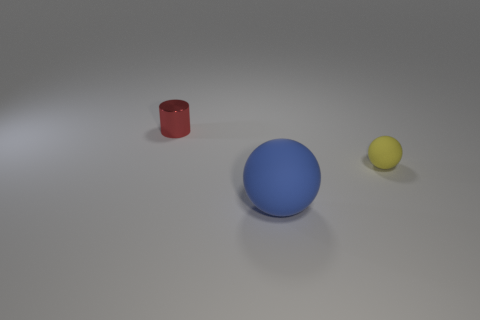How many other objects are there of the same size as the blue object?
Provide a succinct answer. 0. What color is the small thing in front of the tiny red cylinder behind the sphere right of the large blue sphere?
Provide a short and direct response. Yellow. What is the size of the object that is in front of the small red metal object and behind the blue matte sphere?
Offer a terse response. Small. How many other things are the same shape as the metallic thing?
Make the answer very short. 0. What number of spheres are tiny rubber things or matte things?
Offer a terse response. 2. There is a tiny thing that is on the left side of the small thing that is right of the red cylinder; are there any small yellow objects left of it?
Your answer should be compact. No. What color is the other large matte thing that is the same shape as the yellow matte object?
Keep it short and to the point. Blue. What number of gray objects are shiny cylinders or rubber spheres?
Ensure brevity in your answer.  0. There is a small thing to the left of the sphere that is to the right of the big blue rubber sphere; what is its material?
Provide a short and direct response. Metal. Is the shape of the small red shiny object the same as the small yellow object?
Ensure brevity in your answer.  No. 